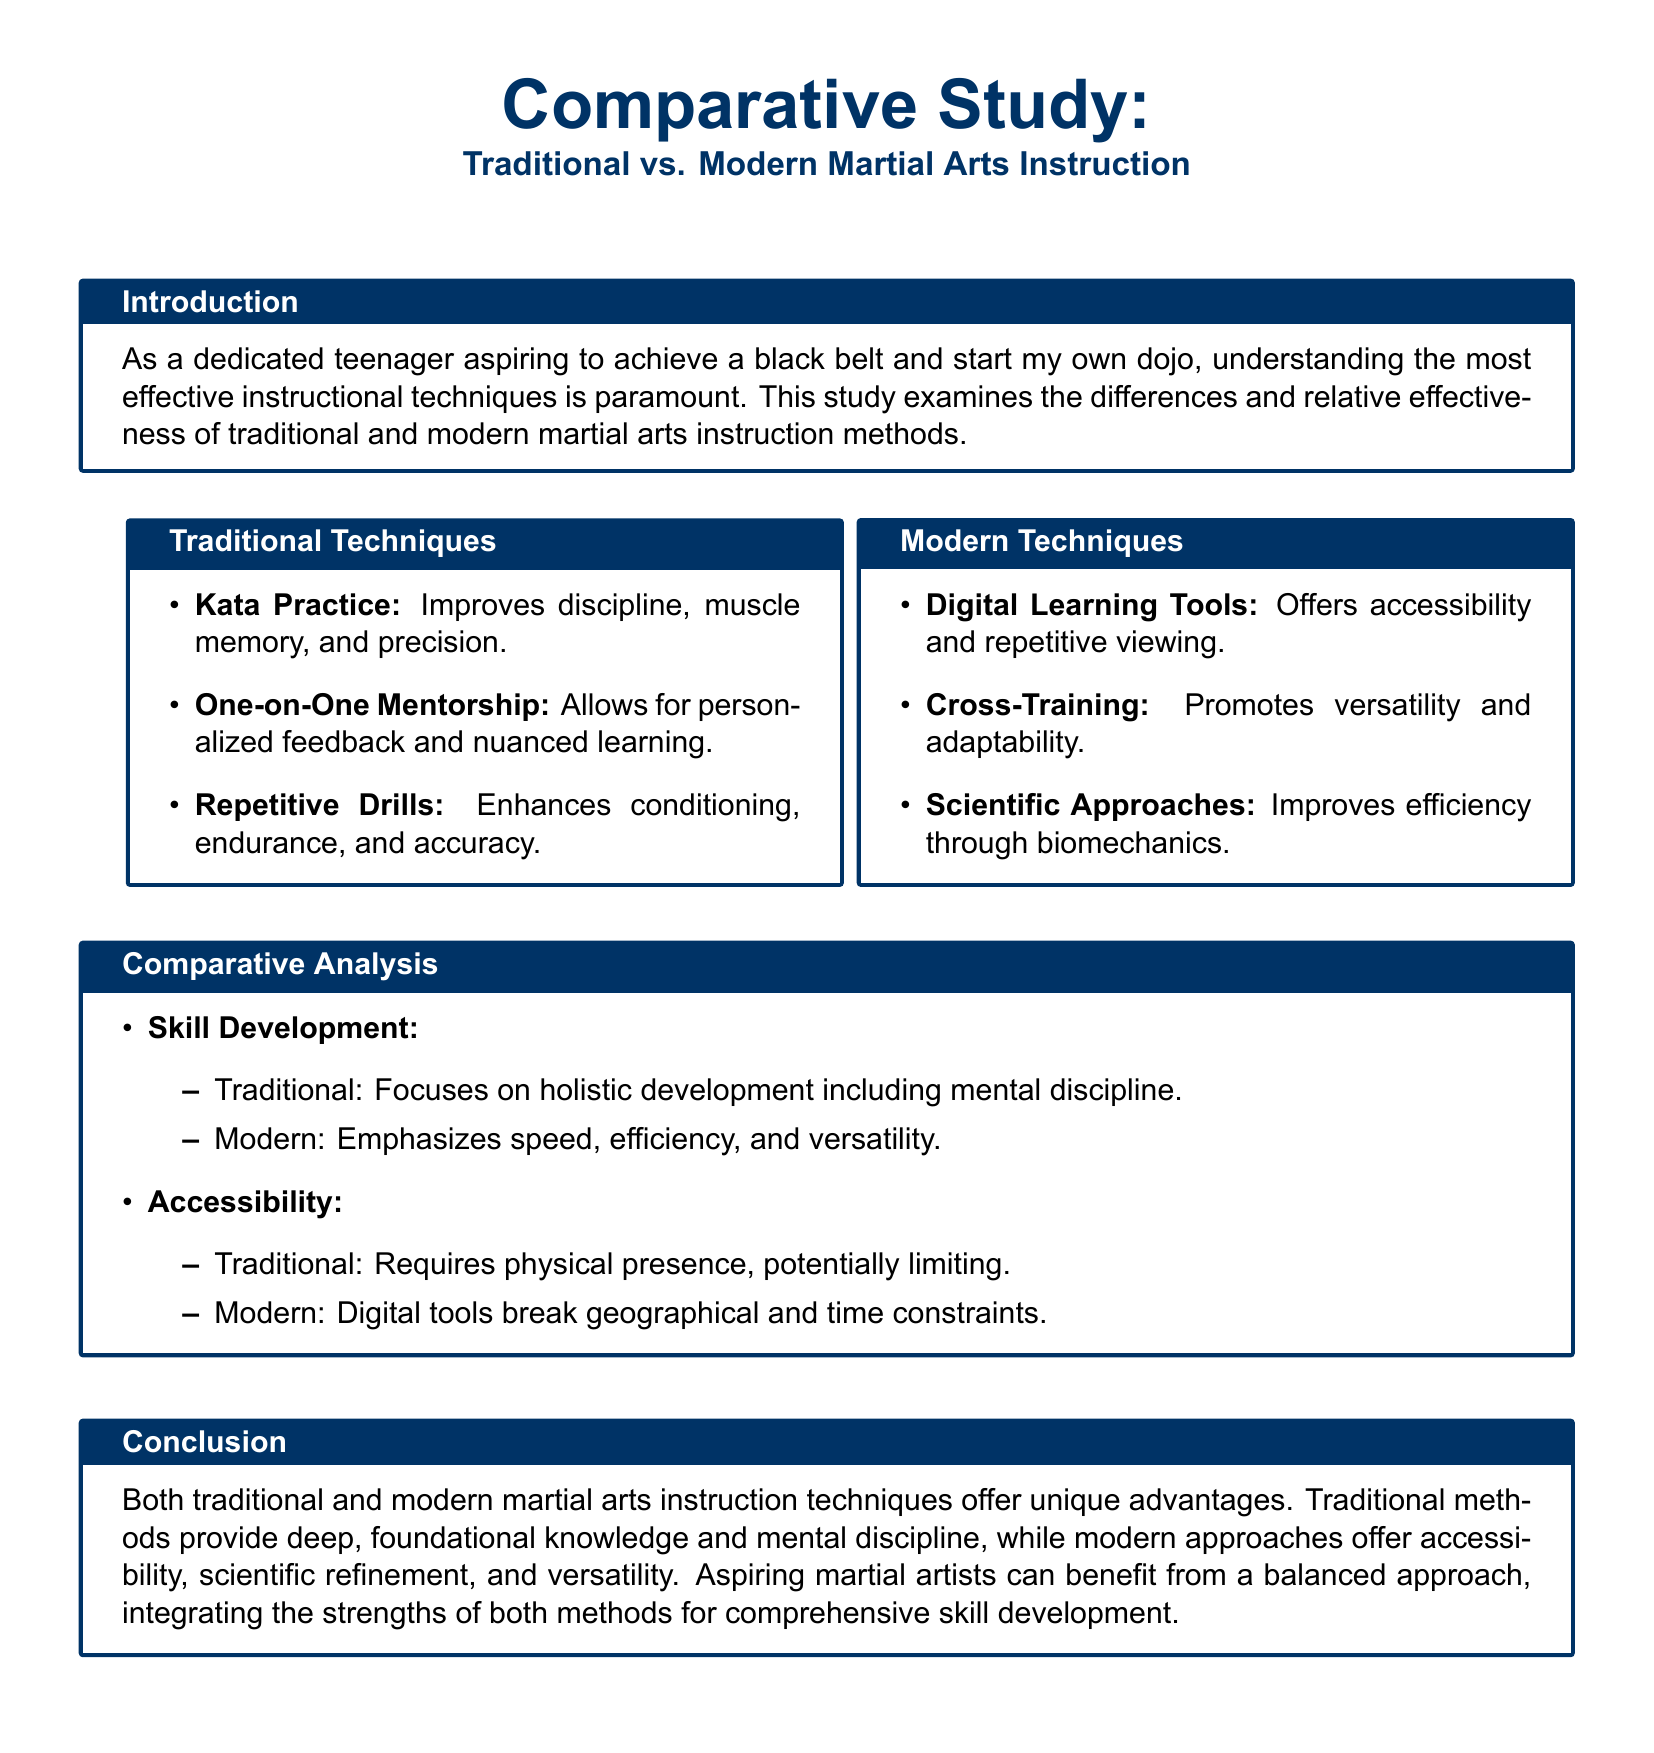What is the purpose of this study? The study aims to examine the differences and effectiveness of traditional and modern martial arts instruction methods.
Answer: to examine the differences and effectiveness of traditional and modern martial arts instruction methods What method focuses on discipline, muscle memory, and precision? This method is associated with traditional martial arts and involves specified practice routines.
Answer: Kata Practice What is one modern technique mentioned for accessibility? This technique utilizes digital platforms to improve accessibility in learning martial arts.
Answer: Digital Learning Tools How does traditional skill development differ from modern skill development? Traditional skill development emphasizes mental discipline, while modern focuses on speed and efficiency.
Answer: Traditional focuses on holistic development including mental discipline; Modern emphasizes speed, efficiency, and versatility Which instructional technique allows for personalized feedback? This technique is a hallmark of traditional instruction methods that involve direct interaction with a mentor.
Answer: One-on-One Mentorship What does modern instruction emphasize according to the analysis? The modern instruction techniques prioritize adapting methods to individual needs and scientific efficiency.
Answer: Speed, efficiency, and versatility What balance does the conclusion suggest for aspiring martial artists? The conclusion recommends integrating both traditional and modern techniques for comprehensive skill development.
Answer: A balanced approach integrating the strengths of both methods What is one benefit of digital tools mentioned in the modern techniques? This benefit is associated with viewing and re-viewing instructional material without physical constraints.
Answer: Offers accessibility and repetitive viewing 